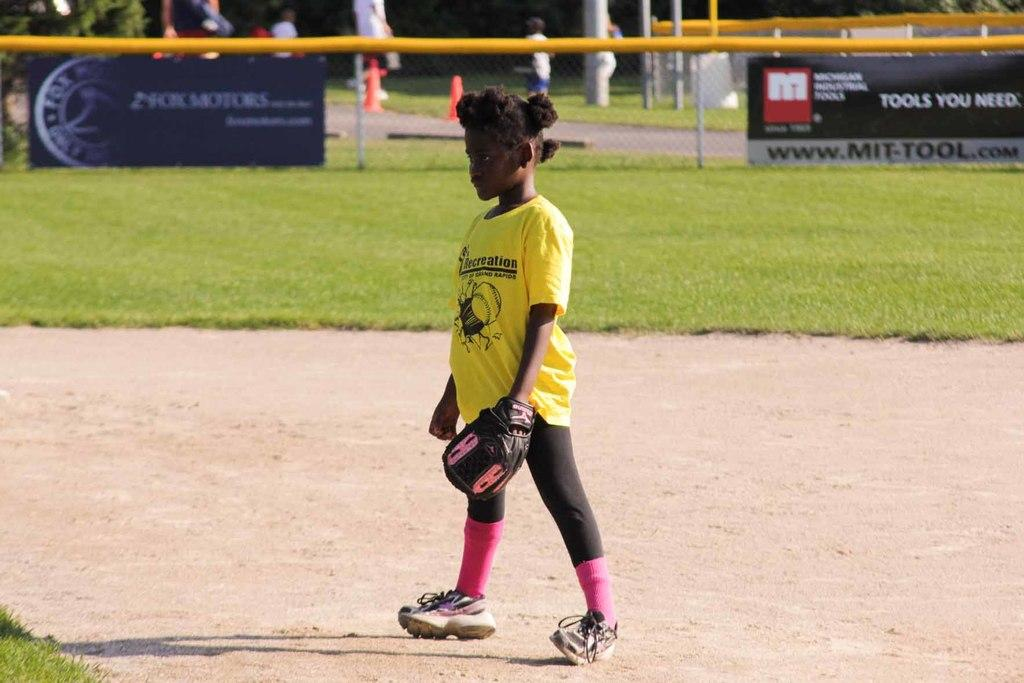<image>
Offer a succinct explanation of the picture presented. a little girl on a baseball field with a shirt that says 'recreation' on it 